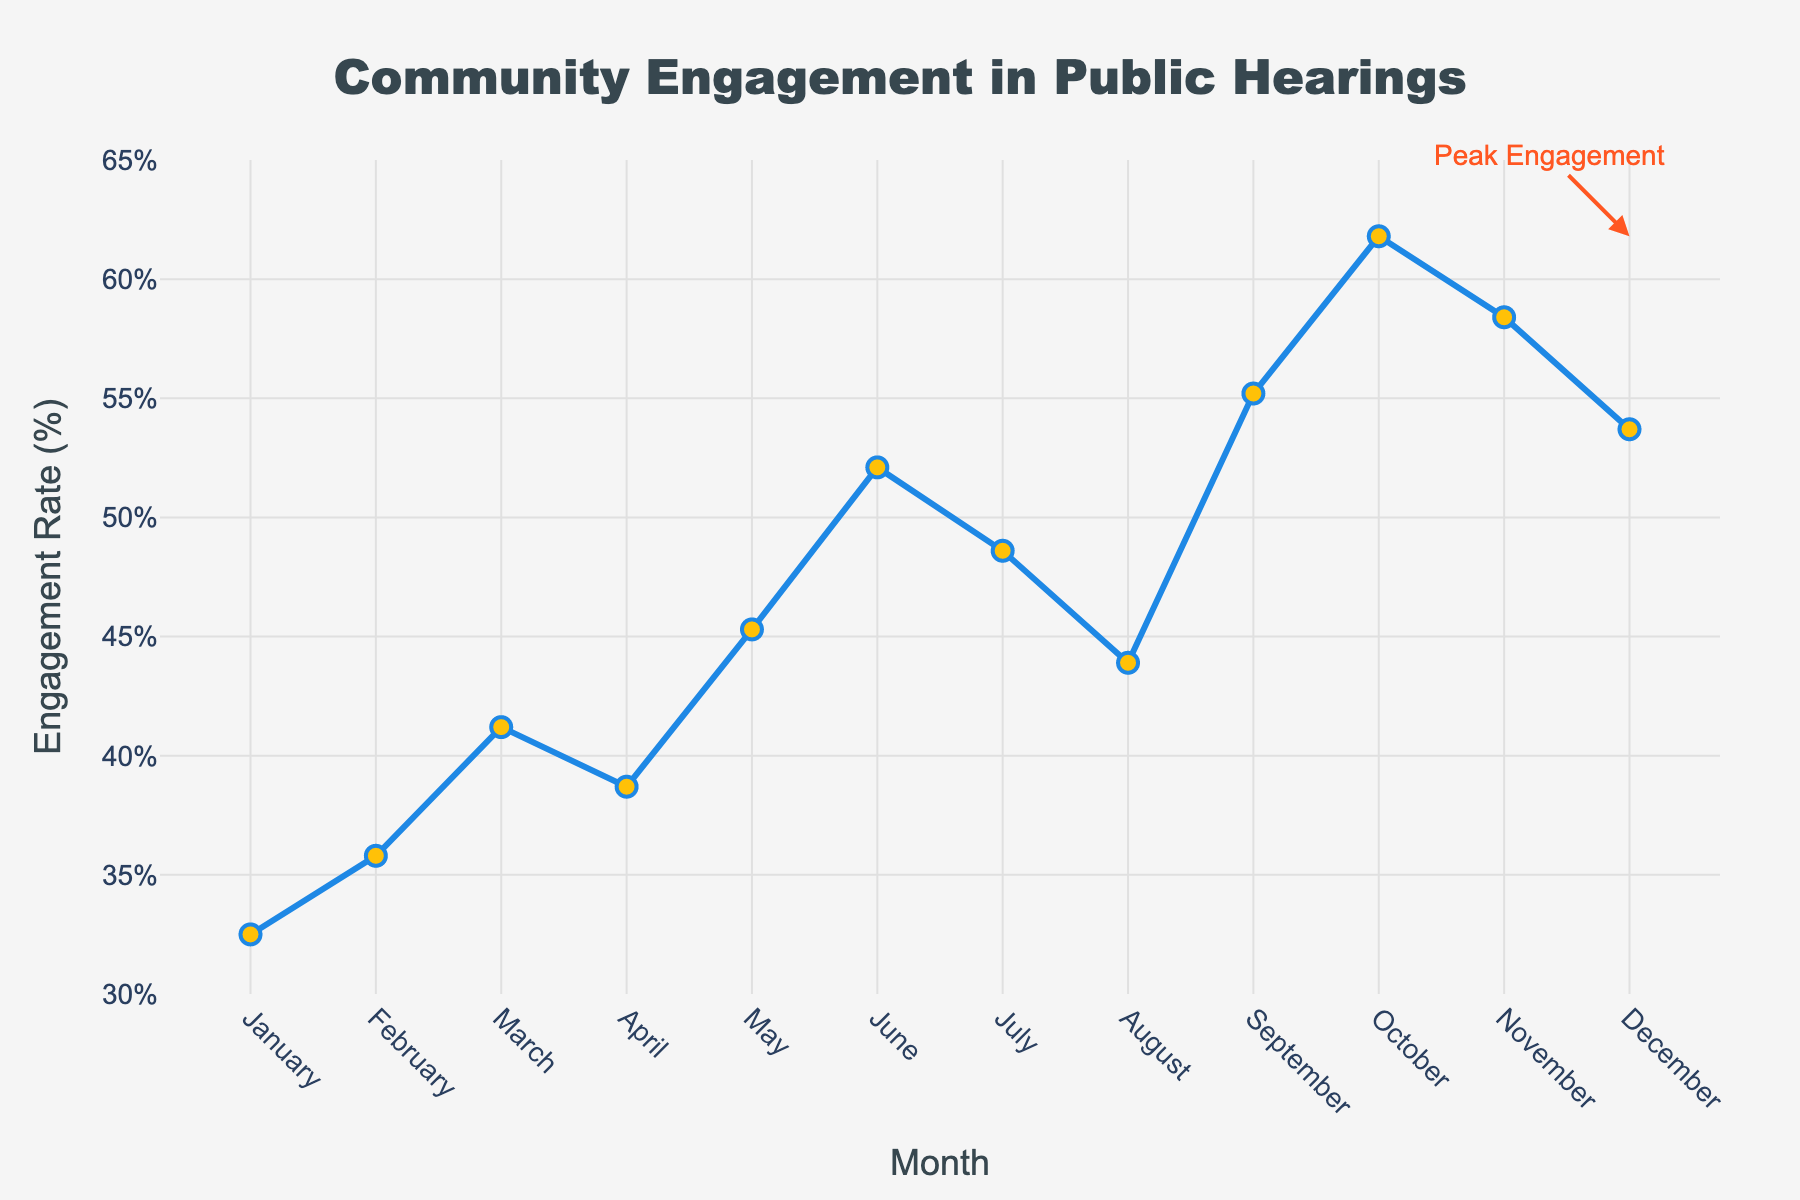what's the peak engagement rate and when does it occur? The peak engagement rate is identified by the annotation on the figure. It highlights the highest rate in October, reaching 61.8%.
Answer: 61.8%, October Which month showed the lowest engagement rate? By looking at the lowest point on the line graph, engagement is at its minimum in January at 32.5%.
Answer: January How does the engagement rate in May compare to July? May's engagement rate is 45.3%, which is lower than July's 48.6%. Comparing the two, July's rate is higher.
Answer: July is higher What is the average engagement rate from January to June? Calculate the sum of the engagement rates from January to June (32.5 + 35.8 + 41.2 + 38.7 + 45.3 + 52.1 = 245.6). Divide this sum by the number of months (245.6 / 6). The average engagement rate is approximately 40.93%.
Answer: 40.93% What month(s) experienced the sharpest increase in engagement rate? By examining the steepest slopes on the line graph, the largest increase is between September and October where the rate jumps from 55.2% to 61.8%.
Answer: September to October What is the total increase in engagement rate from January to December? Subtract January's engagement rate from December's (53.7% - 32.5%). The total increase is 21.2%.
Answer: 21.2% Which months had an engagement rate above 50%? Reviewing the line graph for rates exceeding 50%, the months are June, September, October, November, and December.
Answer: June, September, October, November, December In which month(s) did the engagement rate decrease compared to the previous month? Inspecting the downward slopes, April (38.7%), July (48.6%), and August (43.9%) saw decreases from their previous months.
Answer: April, July, August What's the average engagement rate in the second half of the year (July to December)? Sum the engagement rates from July to December (48.6 + 43.9 + 55.2 + 61.8 + 58.4 + 53.7 = 321.6). Divide this sum by six months. The average rate is 53.6%.
Answer: 53.6% By how much did the engagement rate change from February to March? Subtract February's rate from March's (41.2% - 35.8%). The change is an increase of 5.4%.
Answer: 5.4% 